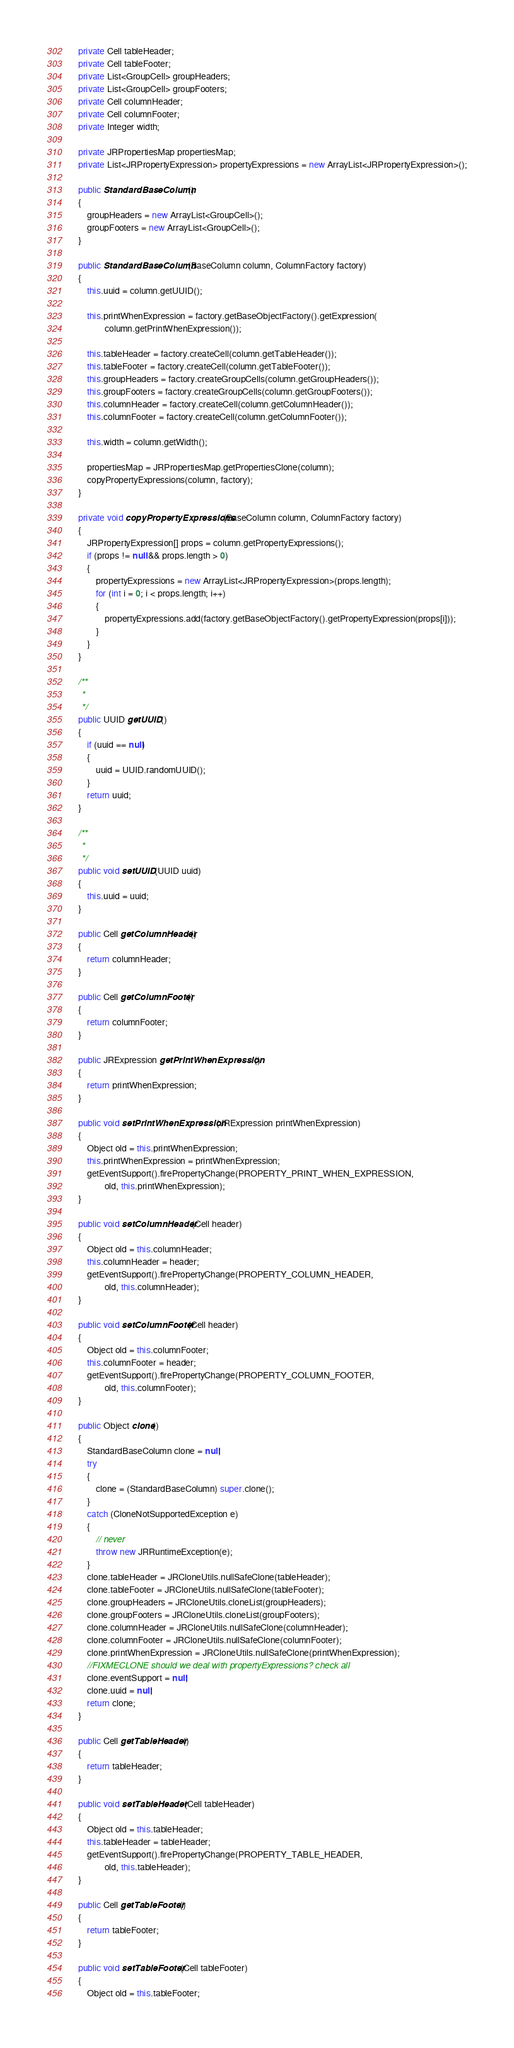Convert code to text. <code><loc_0><loc_0><loc_500><loc_500><_Java_>	private Cell tableHeader;
	private Cell tableFooter;
	private List<GroupCell> groupHeaders; 
	private List<GroupCell> groupFooters; 
	private Cell columnHeader;
	private Cell columnFooter;
	private Integer width;

	private JRPropertiesMap propertiesMap;
	private List<JRPropertyExpression> propertyExpressions = new ArrayList<JRPropertyExpression>();

	public StandardBaseColumn()
	{
		groupHeaders = new ArrayList<GroupCell>();
		groupFooters = new ArrayList<GroupCell>();
	}

	public StandardBaseColumn(BaseColumn column, ColumnFactory factory)
	{
		this.uuid = column.getUUID();

		this.printWhenExpression = factory.getBaseObjectFactory().getExpression(
				column.getPrintWhenExpression());
		
		this.tableHeader = factory.createCell(column.getTableHeader());
		this.tableFooter = factory.createCell(column.getTableFooter());
		this.groupHeaders = factory.createGroupCells(column.getGroupHeaders());
		this.groupFooters = factory.createGroupCells(column.getGroupFooters());
		this.columnHeader = factory.createCell(column.getColumnHeader());
		this.columnFooter = factory.createCell(column.getColumnFooter());

		this.width = column.getWidth();

		propertiesMap = JRPropertiesMap.getPropertiesClone(column);
		copyPropertyExpressions(column, factory);
	}

	private void copyPropertyExpressions(BaseColumn column, ColumnFactory factory)
	{
		JRPropertyExpression[] props = column.getPropertyExpressions();
		if (props != null && props.length > 0)
		{
			propertyExpressions = new ArrayList<JRPropertyExpression>(props.length);
			for (int i = 0; i < props.length; i++)
			{
				propertyExpressions.add(factory.getBaseObjectFactory().getPropertyExpression(props[i]));
			}
		}
	}
	
	/**
	 *
	 */
	public UUID getUUID()
	{
		if (uuid == null)
		{
			uuid = UUID.randomUUID();
		}
		return uuid;
	}

	/**
	 *
	 */
	public void setUUID(UUID uuid)
	{
		this.uuid = uuid;
	}
		
	public Cell getColumnHeader()
	{
		return columnHeader;
	}
	
	public Cell getColumnFooter()
	{
		return columnFooter;
	}

	public JRExpression getPrintWhenExpression()
	{
		return printWhenExpression;
	}

	public void setPrintWhenExpression(JRExpression printWhenExpression)
	{
		Object old = this.printWhenExpression;
		this.printWhenExpression = printWhenExpression;
		getEventSupport().firePropertyChange(PROPERTY_PRINT_WHEN_EXPRESSION, 
				old, this.printWhenExpression);
	}

	public void setColumnHeader(Cell header)
	{
		Object old = this.columnHeader;
		this.columnHeader = header;
		getEventSupport().firePropertyChange(PROPERTY_COLUMN_HEADER, 
				old, this.columnHeader);
	}

	public void setColumnFooter(Cell header)
	{
		Object old = this.columnFooter;
		this.columnFooter = header;
		getEventSupport().firePropertyChange(PROPERTY_COLUMN_FOOTER, 
				old, this.columnFooter);
	}
	
	public Object clone()
	{
		StandardBaseColumn clone = null;
		try
		{
			clone = (StandardBaseColumn) super.clone();
		} 
		catch (CloneNotSupportedException e)
		{
			// never
			throw new JRRuntimeException(e);
		}
		clone.tableHeader = JRCloneUtils.nullSafeClone(tableHeader);
		clone.tableFooter = JRCloneUtils.nullSafeClone(tableFooter);
		clone.groupHeaders = JRCloneUtils.cloneList(groupHeaders);
		clone.groupFooters = JRCloneUtils.cloneList(groupFooters);
		clone.columnHeader = JRCloneUtils.nullSafeClone(columnHeader);
		clone.columnFooter = JRCloneUtils.nullSafeClone(columnFooter);
		clone.printWhenExpression = JRCloneUtils.nullSafeClone(printWhenExpression);
		//FIXMECLONE should we deal with propertyExpressions? check all
		clone.eventSupport = null;
		clone.uuid = null;
		return clone;
	}

	public Cell getTableHeader()
	{
		return tableHeader;
	}

	public void setTableHeader(Cell tableHeader)
	{
		Object old = this.tableHeader;
		this.tableHeader = tableHeader;
		getEventSupport().firePropertyChange(PROPERTY_TABLE_HEADER, 
				old, this.tableHeader);
	}

	public Cell getTableFooter()
	{
		return tableFooter;
	}

	public void setTableFooter(Cell tableFooter)
	{
		Object old = this.tableFooter;</code> 